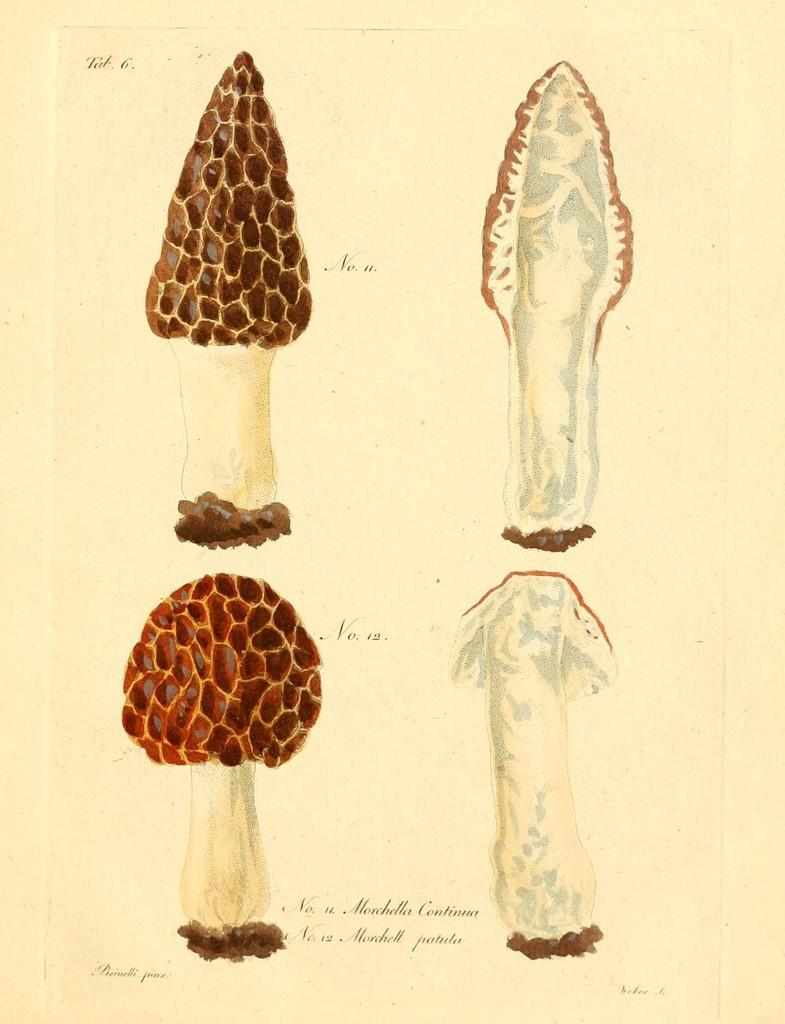What is the main object in the image? The image contains a paper. What is depicted on the paper? There are pictures of trees on the paper. Is there any text on the paper? Yes, there is text at the bottom of the paper. What type of waste is visible in the image? There is no waste visible in the image; it only contains a paper with pictures of trees and text. How many bananas are depicted in the image? There are no bananas present in the image. 